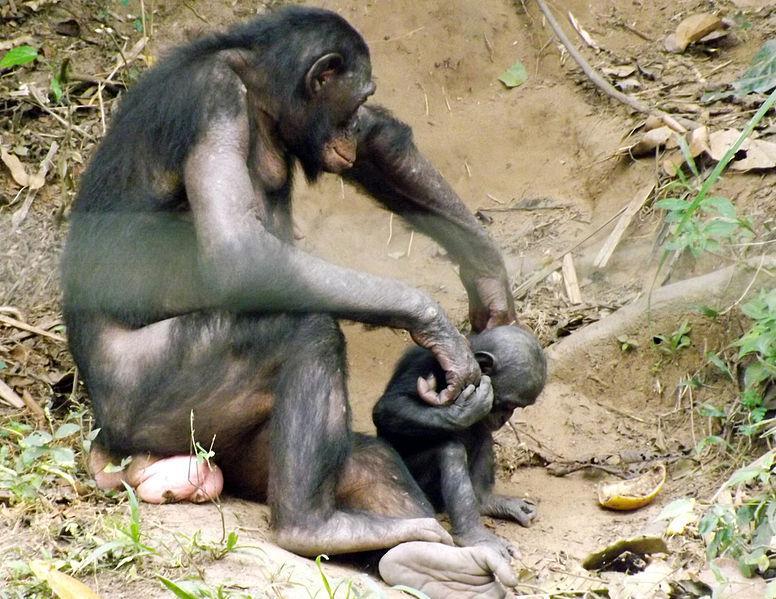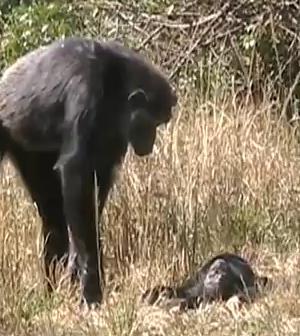The first image is the image on the left, the second image is the image on the right. Assess this claim about the two images: "An image shows at least one chimp bent downward to look at a tiny body lying on the ground.". Correct or not? Answer yes or no. Yes. The first image is the image on the left, the second image is the image on the right. Assess this claim about the two images: "There is a total of four chimpanzees in the image pair.". Correct or not? Answer yes or no. Yes. The first image is the image on the left, the second image is the image on the right. Given the left and right images, does the statement "An image shows at least one adult chimp looking at a tiny body lying on the ground." hold true? Answer yes or no. Yes. 